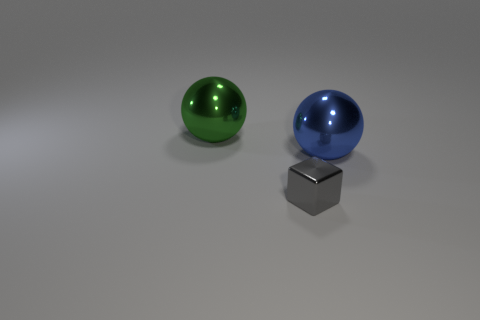There is a sphere left of the large blue shiny ball; what number of gray metallic cubes are in front of it?
Offer a very short reply. 1. The other metal ball that is the same size as the blue metallic sphere is what color?
Offer a terse response. Green. There is a thing that is left of the blue metal sphere and behind the tiny shiny thing; what is it made of?
Keep it short and to the point. Metal. Do the thing behind the blue object and the big blue ball have the same size?
Your answer should be very brief. Yes. The blue shiny object is what shape?
Your response must be concise. Sphere. How many large blue metal things have the same shape as the large green object?
Keep it short and to the point. 1. How many spheres are behind the blue metallic thing and in front of the large green shiny object?
Provide a short and direct response. 0. The metallic block has what color?
Your response must be concise. Gray. Is there a big object made of the same material as the big blue sphere?
Ensure brevity in your answer.  Yes. There is a big shiny ball that is behind the big sphere that is to the right of the small gray metallic thing; are there any blue shiny objects that are left of it?
Give a very brief answer. No. 